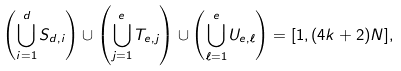Convert formula to latex. <formula><loc_0><loc_0><loc_500><loc_500>\left ( \bigcup _ { i = 1 } ^ { d } S _ { d , i } \right ) \cup \left ( \bigcup _ { j = 1 } ^ { e } T _ { e , j } \right ) \cup \left ( \bigcup _ { \ell = 1 } ^ { e } U _ { e , \ell } \right ) = [ 1 , ( 4 k + 2 ) N ] ,</formula> 